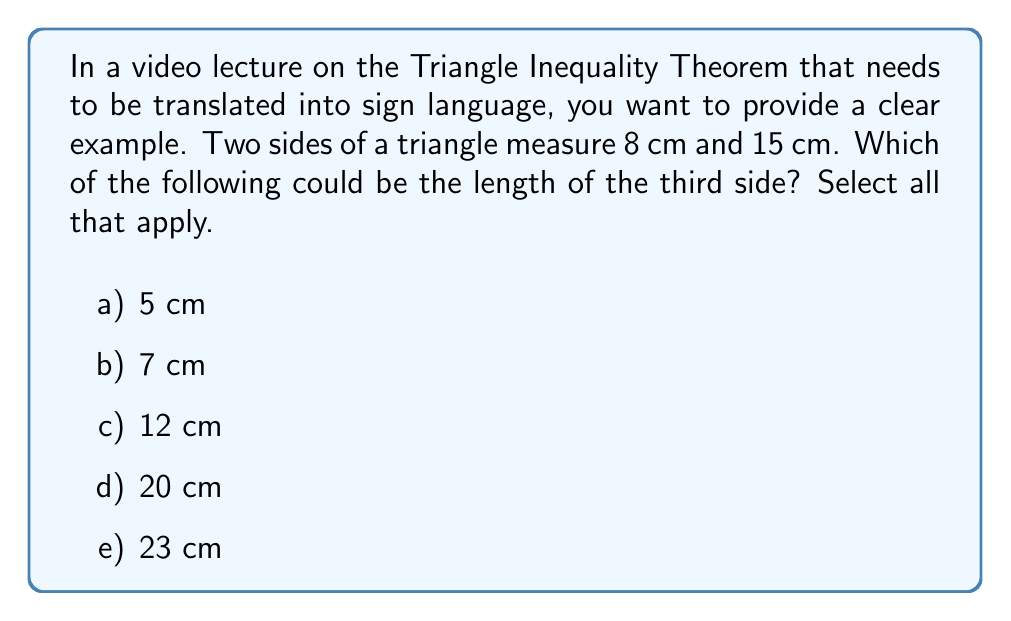Help me with this question. To solve this problem, we need to apply the Triangle Inequality Theorem. This theorem states that the sum of the lengths of any two sides of a triangle must be greater than the length of the remaining side. Also, the difference between the lengths of any two sides must be less than the length of the remaining side.

Let's denote the third side as $x$ cm. We know that:
$$a = 8 \text{ cm}$$
$$b = 15 \text{ cm}$$

For $x$ to be a valid side length, it must satisfy these three inequalities:

1) $a + b > x$, i.e., $8 + 15 > x$ or $23 > x$
2) $a + x > b$, i.e., $8 + x > 15$ or $x > 7$
3) $b + x > a$, i.e., $15 + x > 8$ or $x > -7$ (always true for positive lengths)

Combining inequalities 1 and 2, we get:

$$7 < x < 23$$

Now, let's check each option:

a) 5 cm: This is less than 7, so it's not possible.
b) 7 cm: This equals the lower bound, so it's not possible.
c) 12 cm: This is between 7 and 23, so it's possible.
d) 20 cm: This is between 7 and 23, so it's possible.
e) 23 cm: This equals the upper bound, so it's not possible.
Answer: The possible lengths for the third side are c) 12 cm and d) 20 cm. 